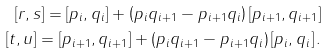Convert formula to latex. <formula><loc_0><loc_0><loc_500><loc_500>\left [ r , s \right ] = \left [ p _ { i } , q _ { i } \right ] + \left ( p _ { i } q _ { i + 1 } - p _ { i + 1 } q _ { i } \right ) \left [ p _ { i + 1 } , q _ { i + 1 } \right ] \\ \left [ t , u \right ] = \left [ p _ { i + 1 } , q _ { i + 1 } \right ] + \left ( p _ { i } q _ { i + 1 } - p _ { i + 1 } q _ { i } \right ) \left [ p _ { i } , q _ { i } \right ] .</formula> 